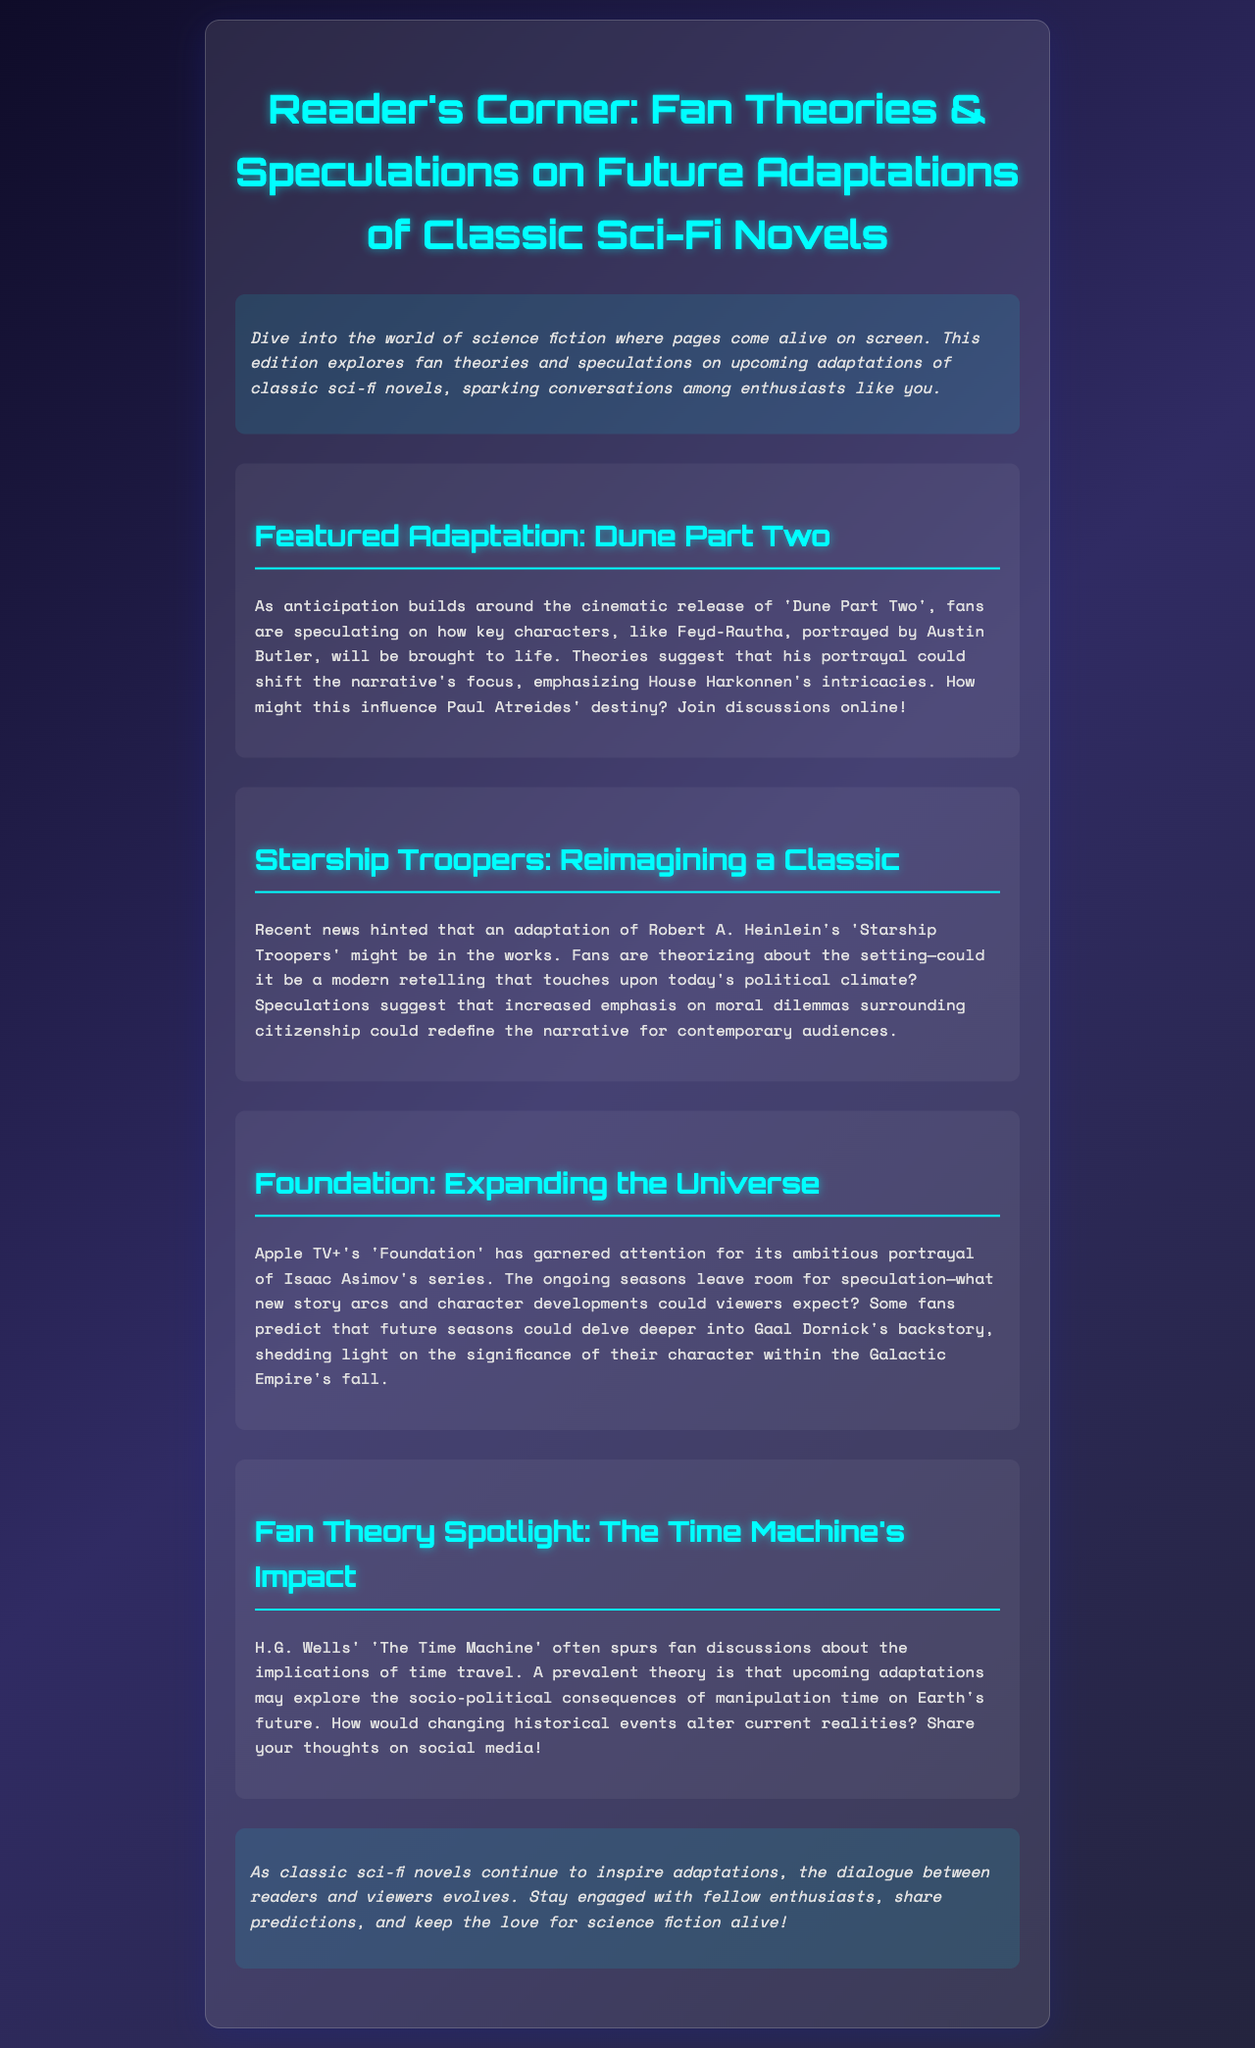what is the title of the featured adaptation? The title mentioned in the document is the one highlighted in the Featured Adaptation section.
Answer: Dune Part Two who portrays Feyd-Rautha in Dune Part Two? The document specifies the name of the actor in connection with the featured adaptation.
Answer: Austin Butler what novel is considered for a modern retelling in the newsletter? The document discusses a specific classic sci-fi novel that may be reimagined based on current political themes.
Answer: Starship Troopers which platform is airing the series 'Foundation'? The document identifies the streaming service linked to the adaptation discussed in the newsletter.
Answer: Apple TV+ what major theme is explored by fans regarding 'The Time Machine'? The document points out a recurring theme in fan discussions about H.G. Wells' novel.
Answer: Time travel how many adaptation discussions are mentioned in the newsletter? The number can be calculated based on the sections outlined in the document.
Answer: Four what type of content does the newsletter primarily focus on? The document reveals the general subject matter covered in the newsletter title.
Answer: Fan theories and speculations what is the primary focus of the 'Starship Troopers' adaptation discussions? The document highlights a contemporary relevance tied to the classic novel.
Answer: Political climate 